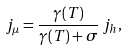<formula> <loc_0><loc_0><loc_500><loc_500>j _ { \mu } = \frac { \gamma ( T ) } { \gamma ( T ) + \sigma } \, j _ { h } ,</formula> 